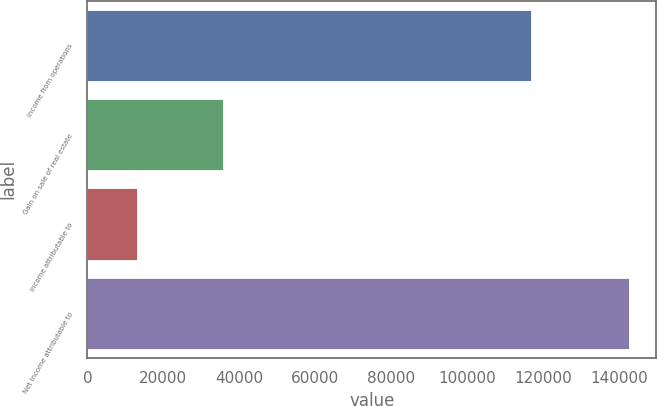<chart> <loc_0><loc_0><loc_500><loc_500><bar_chart><fcel>Income from operations<fcel>Gain on sale of real estate<fcel>Income attributable to<fcel>Net income attributable to<nl><fcel>116937<fcel>35606<fcel>13139.4<fcel>142736<nl></chart> 